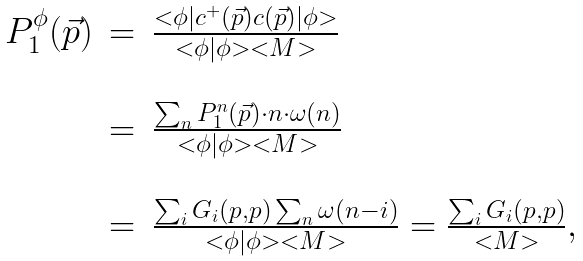Convert formula to latex. <formula><loc_0><loc_0><loc_500><loc_500>\begin{array} { l c l } P _ { 1 } ^ { \phi } ( \vec { p } ) & = & \frac { < \phi | c ^ { + } ( \vec { p } ) c ( \vec { p } ) | \phi > } { < \phi | \phi > < M > } \\ & & \\ & = & \frac { \sum _ { n } P _ { 1 } ^ { n } ( \vec { p } ) \cdot n \cdot \omega ( n ) } { < \phi | \phi > < M > } \\ & & \\ & = & \frac { \sum _ { i } G _ { i } ( p , p ) \sum _ { n } \omega ( n - i ) } { < \phi | \phi > < M > } = \frac { \sum _ { i } G _ { i } ( p , p ) } { < M > } , \\ \end{array}</formula> 